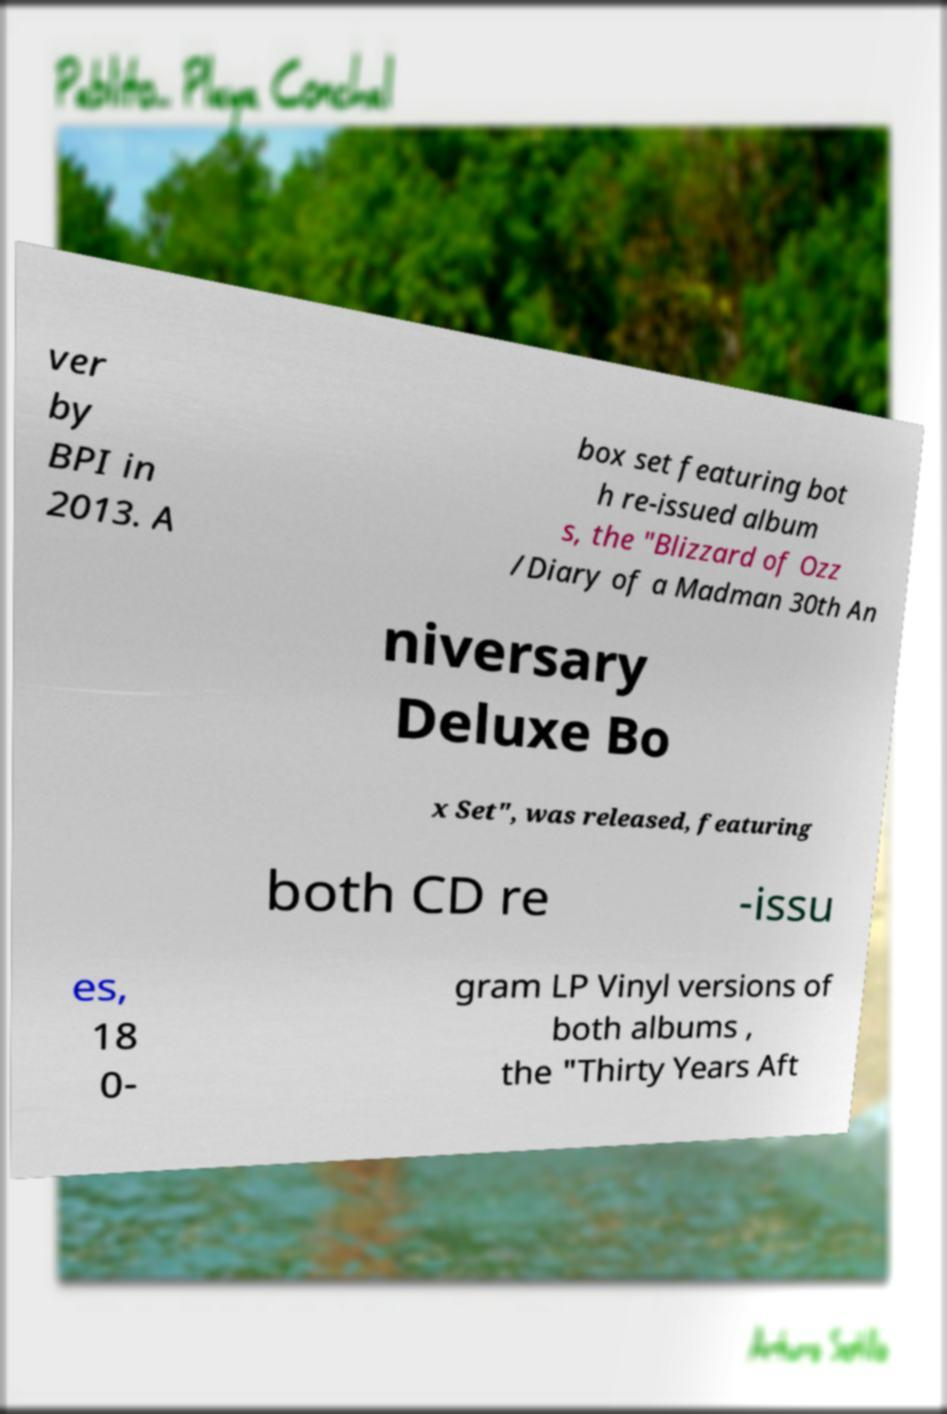Can you accurately transcribe the text from the provided image for me? ver by BPI in 2013. A box set featuring bot h re-issued album s, the "Blizzard of Ozz /Diary of a Madman 30th An niversary Deluxe Bo x Set", was released, featuring both CD re -issu es, 18 0- gram LP Vinyl versions of both albums , the "Thirty Years Aft 